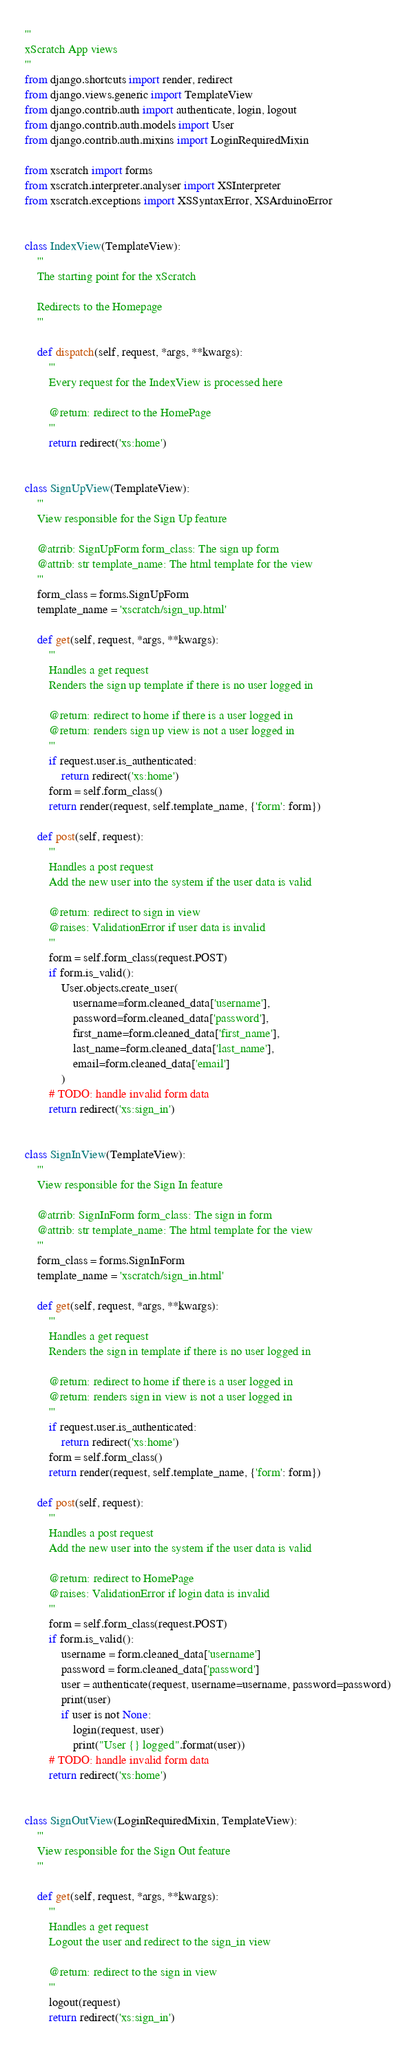<code> <loc_0><loc_0><loc_500><loc_500><_Python_>'''
xScratch App views
'''
from django.shortcuts import render, redirect
from django.views.generic import TemplateView
from django.contrib.auth import authenticate, login, logout
from django.contrib.auth.models import User
from django.contrib.auth.mixins import LoginRequiredMixin

from xscratch import forms
from xscratch.interpreter.analyser import XSInterpreter
from xscratch.exceptions import XSSyntaxError, XSArduinoError


class IndexView(TemplateView):
    '''
    The starting point for the xScratch

    Redirects to the Homepage
    '''

    def dispatch(self, request, *args, **kwargs):
        '''
        Every request for the IndexView is processed here

        @return: redirect to the HomePage
        '''
        return redirect('xs:home')


class SignUpView(TemplateView):
    '''
    View responsible for the Sign Up feature

    @atrrib: SignUpForm form_class: The sign up form
    @attrib: str template_name: The html template for the view
    '''
    form_class = forms.SignUpForm
    template_name = 'xscratch/sign_up.html'

    def get(self, request, *args, **kwargs):
        '''
        Handles a get request
        Renders the sign up template if there is no user logged in

        @return: redirect to home if there is a user logged in
        @return: renders sign up view is not a user logged in
        '''
        if request.user.is_authenticated:
            return redirect('xs:home')
        form = self.form_class()
        return render(request, self.template_name, {'form': form})

    def post(self, request):
        '''
        Handles a post request
        Add the new user into the system if the user data is valid

        @return: redirect to sign in view
        @raises: ValidationError if user data is invalid
        '''
        form = self.form_class(request.POST)
        if form.is_valid():
            User.objects.create_user(
                username=form.cleaned_data['username'],
                password=form.cleaned_data['password'],
                first_name=form.cleaned_data['first_name'],
                last_name=form.cleaned_data['last_name'],
                email=form.cleaned_data['email']
            )
        # TODO: handle invalid form data
        return redirect('xs:sign_in')


class SignInView(TemplateView):
    '''
    View responsible for the Sign In feature

    @atrrib: SignInForm form_class: The sign in form
    @attrib: str template_name: The html template for the view
    '''
    form_class = forms.SignInForm
    template_name = 'xscratch/sign_in.html'

    def get(self, request, *args, **kwargs):
        '''
        Handles a get request
        Renders the sign in template if there is no user logged in

        @return: redirect to home if there is a user logged in
        @return: renders sign in view is not a user logged in
        '''
        if request.user.is_authenticated:
            return redirect('xs:home')
        form = self.form_class()
        return render(request, self.template_name, {'form': form})

    def post(self, request):
        '''
        Handles a post request
        Add the new user into the system if the user data is valid

        @return: redirect to HomePage
        @raises: ValidationError if login data is invalid
        '''
        form = self.form_class(request.POST)
        if form.is_valid():
            username = form.cleaned_data['username']
            password = form.cleaned_data['password']
            user = authenticate(request, username=username, password=password)
            print(user)
            if user is not None:
                login(request, user)
                print("User {} logged".format(user))
        # TODO: handle invalid form data
        return redirect('xs:home')


class SignOutView(LoginRequiredMixin, TemplateView):
    '''
    View responsible for the Sign Out feature
    '''

    def get(self, request, *args, **kwargs):
        '''
        Handles a get request
        Logout the user and redirect to the sign_in view

        @return: redirect to the sign in view
        '''
        logout(request)
        return redirect('xs:sign_in')

</code> 